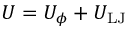Convert formula to latex. <formula><loc_0><loc_0><loc_500><loc_500>U = U _ { \phi } + U _ { L J }</formula> 